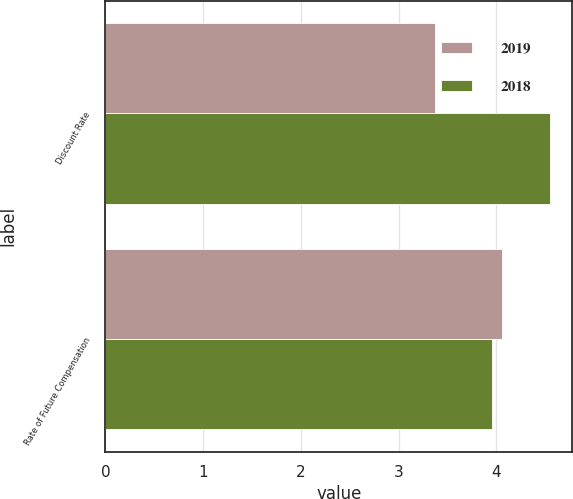Convert chart to OTSL. <chart><loc_0><loc_0><loc_500><loc_500><stacked_bar_chart><ecel><fcel>Discount Rate<fcel>Rate of Future Compensation<nl><fcel>2019<fcel>3.37<fcel>4.06<nl><fcel>2018<fcel>4.55<fcel>3.96<nl></chart> 